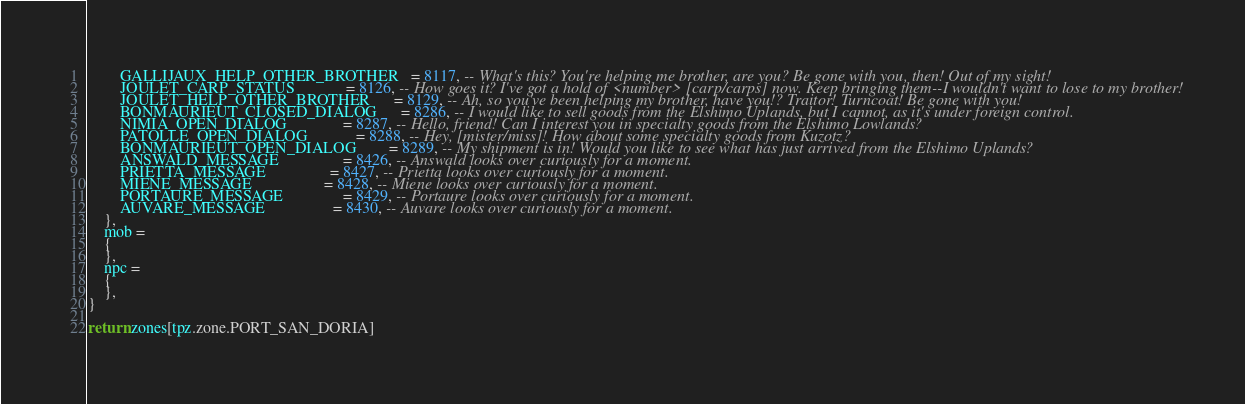Convert code to text. <code><loc_0><loc_0><loc_500><loc_500><_Lua_>        GALLIJAUX_HELP_OTHER_BROTHER   = 8117, -- What's this? You're helping me brother, are you? Be gone with you, then! Out of my sight!
        JOULET_CARP_STATUS             = 8126, -- How goes it? I've got a hold of <number> [carp/carps] now. Keep bringing them--I wouldn't want to lose to my brother!
        JOULET_HELP_OTHER_BROTHER      = 8129, -- Ah, so you've been helping my brother, have you!? Traitor! Turncoat! Be gone with you!
        BONMAURIEUT_CLOSED_DIALOG      = 8286, -- I would like to sell goods from the Elshimo Uplands, but I cannot, as it's under foreign control.
        NIMIA_OPEN_DIALOG              = 8287, -- Hello, friend! Can I interest you in specialty goods from the Elshimo Lowlands?
        PATOLLE_OPEN_DIALOG            = 8288, -- Hey, [mister/miss]! How about some specialty goods from Kuzotz?
        BONMAURIEUT_OPEN_DIALOG        = 8289, -- My shipment is in! Would you like to see what has just arrived from the Elshimo Uplands?
        ANSWALD_MESSAGE                = 8426, -- Answald looks over curiously for a moment.
        PRIETTA_MESSAGE                = 8427, -- Prietta looks over curiously for a moment.
        MIENE_MESSAGE                  = 8428, -- Miene looks over curiously for a moment.
        PORTAURE_MESSAGE               = 8429, -- Portaure looks over curiously for a moment.
        AUVARE_MESSAGE                 = 8430, -- Auvare looks over curiously for a moment.
    },
    mob =
    {
    },
    npc =
    {
    },
}

return zones[tpz.zone.PORT_SAN_DORIA]
</code> 